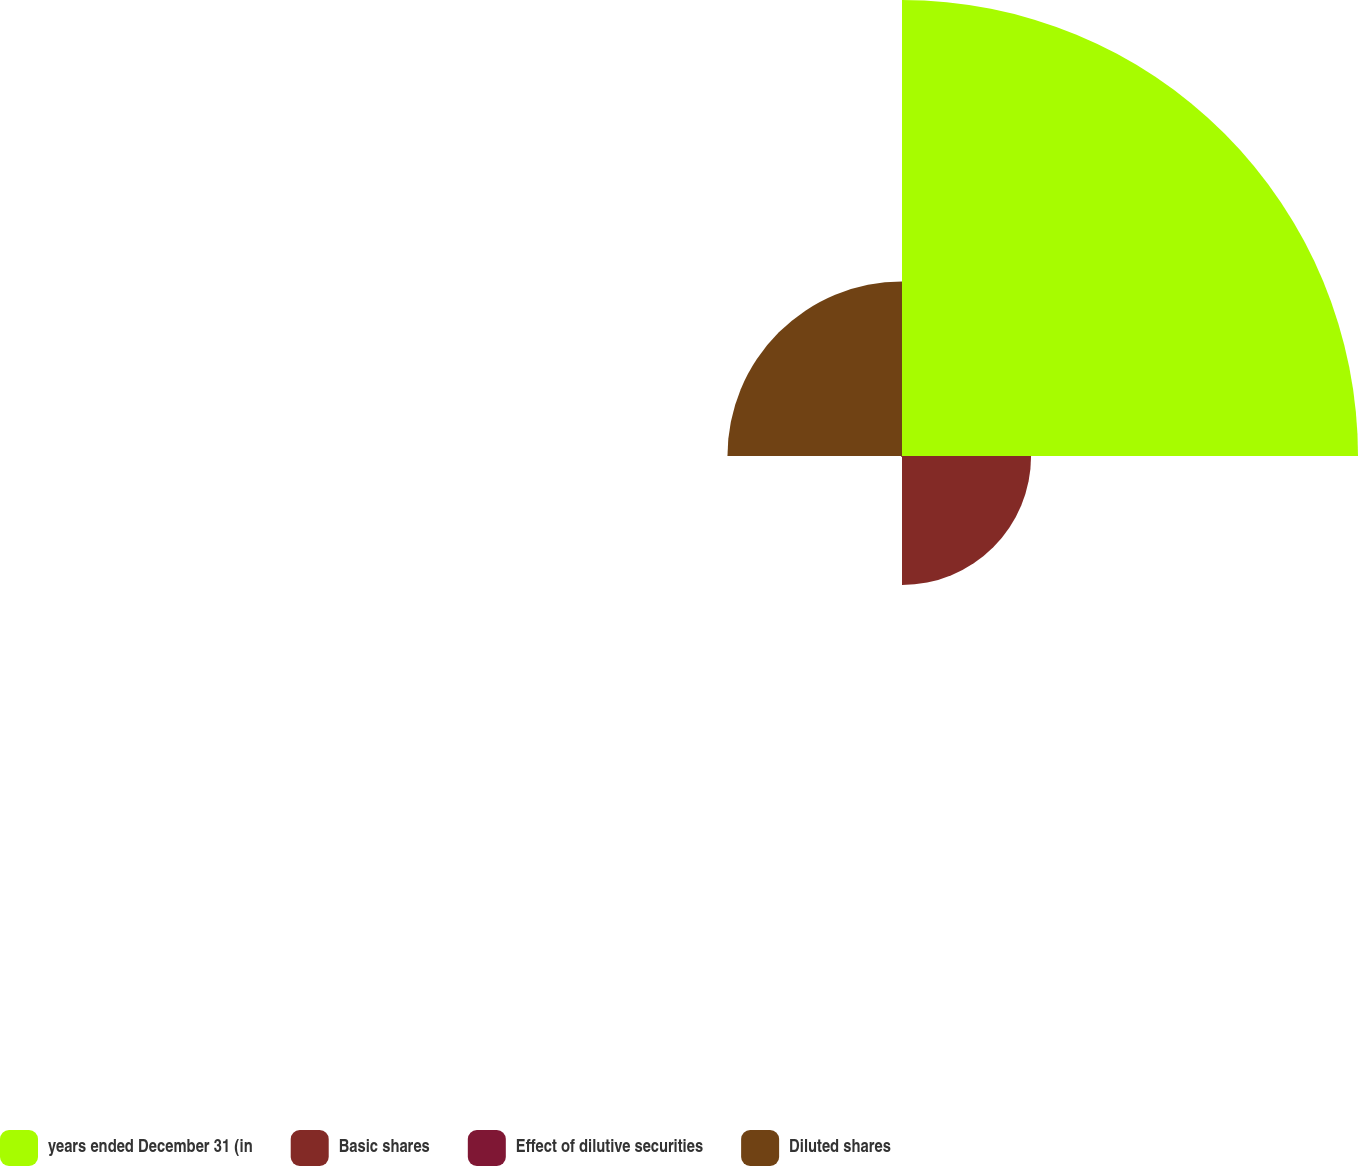Convert chart. <chart><loc_0><loc_0><loc_500><loc_500><pie_chart><fcel>years ended December 31 (in<fcel>Basic shares<fcel>Effect of dilutive securities<fcel>Diluted shares<nl><fcel>59.96%<fcel>16.97%<fcel>0.12%<fcel>22.95%<nl></chart> 